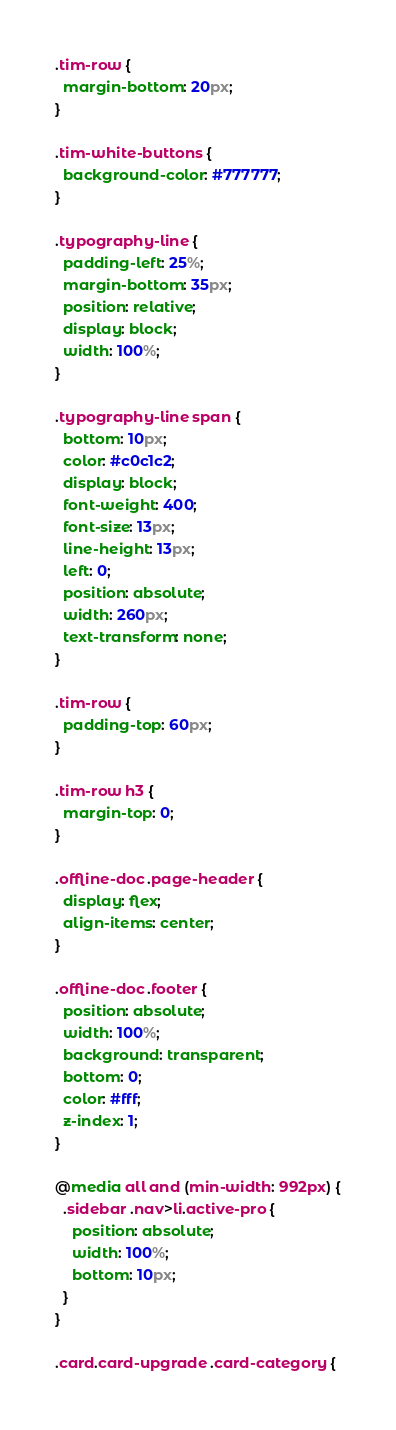<code> <loc_0><loc_0><loc_500><loc_500><_CSS_>.tim-row {
  margin-bottom: 20px;
}

.tim-white-buttons {
  background-color: #777777;
}

.typography-line {
  padding-left: 25%;
  margin-bottom: 35px;
  position: relative;
  display: block;
  width: 100%;
}

.typography-line span {
  bottom: 10px;
  color: #c0c1c2;
  display: block;
  font-weight: 400;
  font-size: 13px;
  line-height: 13px;
  left: 0;
  position: absolute;
  width: 260px;
  text-transform: none;
}

.tim-row {
  padding-top: 60px;
}

.tim-row h3 {
  margin-top: 0;
}

.offline-doc .page-header {
  display: flex;
  align-items: center;
}

.offline-doc .footer {
  position: absolute;
  width: 100%;
  background: transparent;
  bottom: 0;
  color: #fff;
  z-index: 1;
}

@media all and (min-width: 992px) {
  .sidebar .nav>li.active-pro {
    position: absolute;
    width: 100%;
    bottom: 10px;
  }
}

.card.card-upgrade .card-category {</code> 